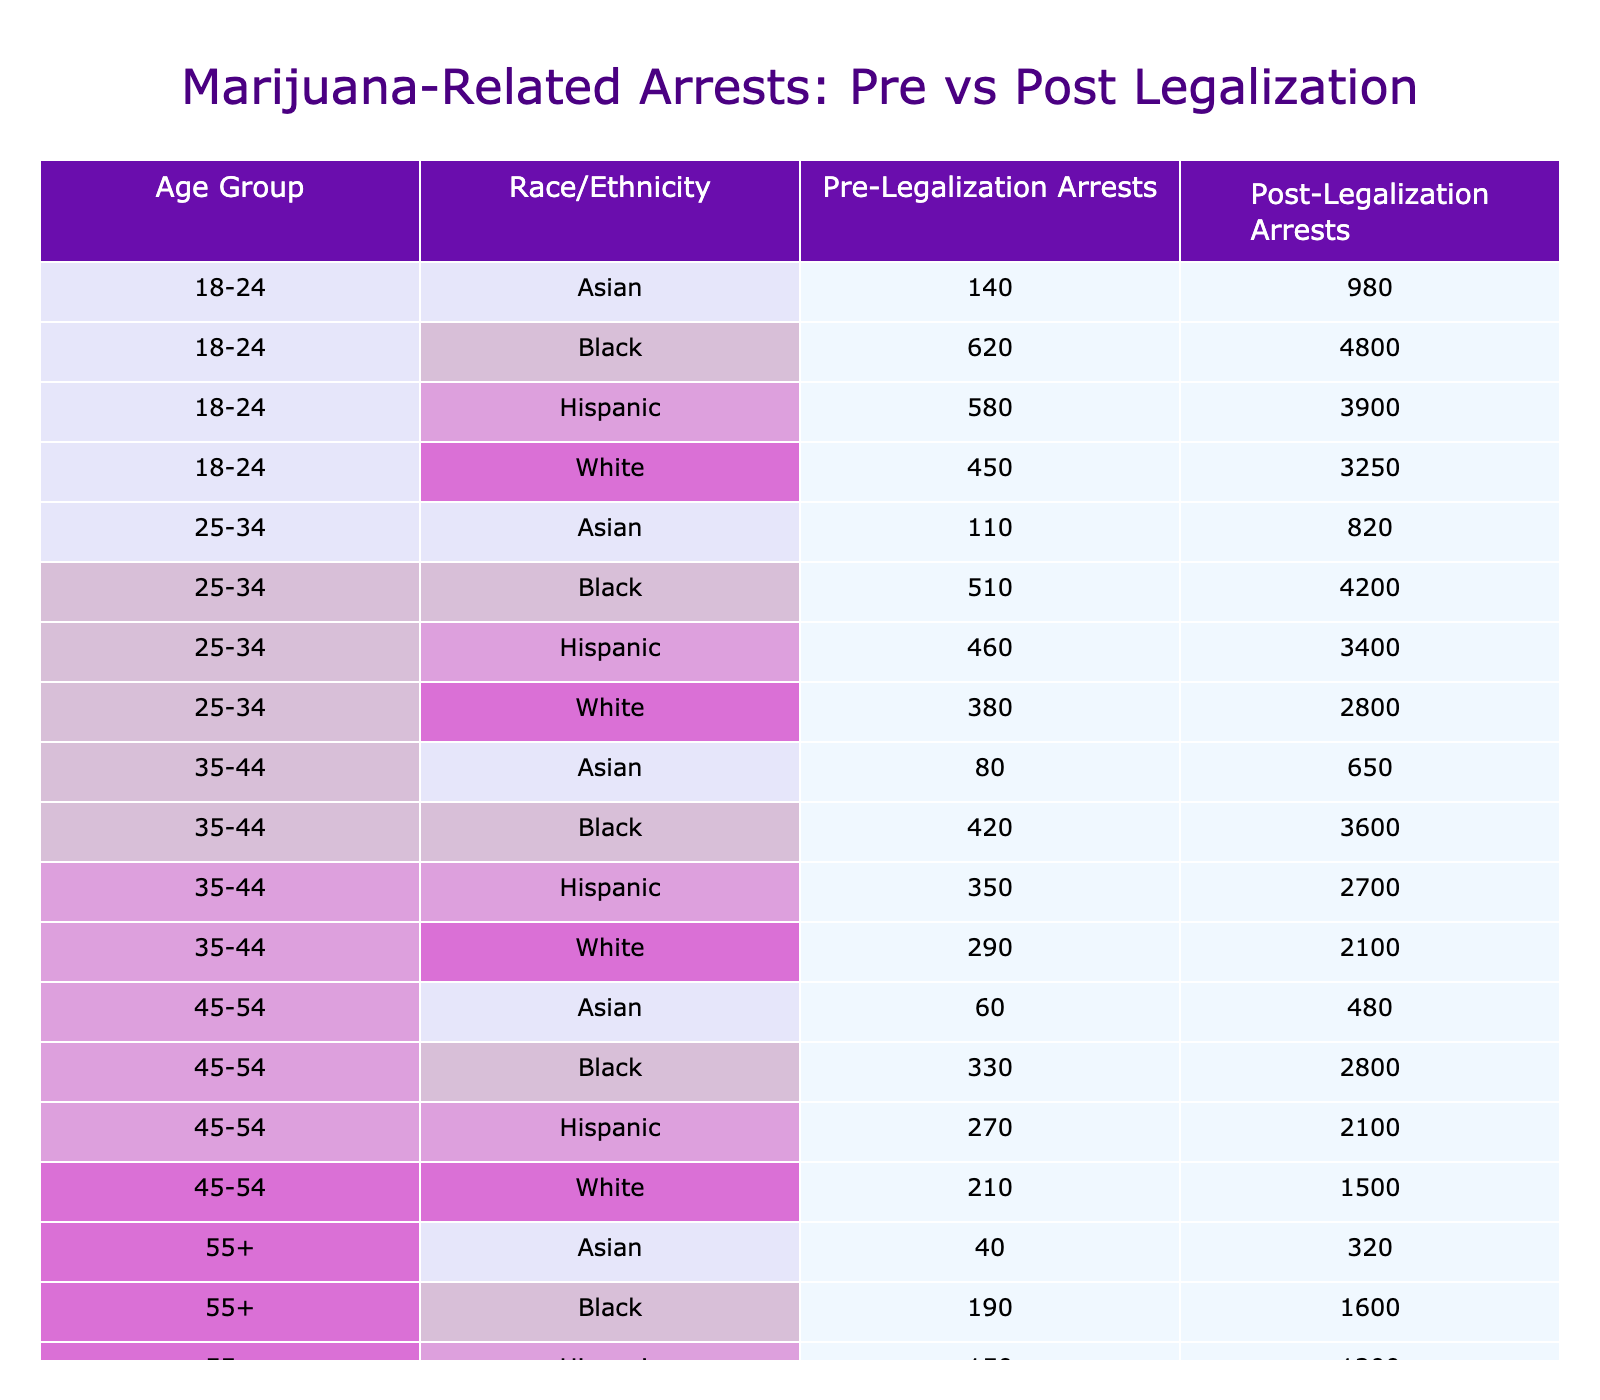What was the total number of pre-legalization arrests for Black individuals in the age group 25-34? The table shows that pre-legalization arrests for Black individuals aged 25-34 were 4200.
Answer: 4200 What was the decrease in arrests for Hispanic individuals in the age group 18-24 after legalization? Pre-legalization arrests for Hispanic individuals aged 18-24 were 3900 and post-legalization arrests were 580. The decrease is calculated as 3900 - 580 = 3320.
Answer: 3320 How many arrests were made post-legalization for individuals aged 55+? Summing all post-legalization arrests for individuals aged 55+ gives: 130 (White) + 190 (Black) + 150 (Hispanic) + 40 (Asian) = 510.
Answer: 510 Did the number of arrests for White individuals aged 35-44 decrease after legalization? Pre-legalization arrests for White individuals aged 35-44 were 2100, while post-legalization arrests were 290. Since 290 is less than 2100, the arrests did decrease.
Answer: Yes What is the average number of pre-legalization arrests across all age groups for Hispanic individuals? The pre-legalization arrests for Hispanic individuals are: 3900 (18-24) + 3400 (25-34) + 2700 (35-44) + 2100 (45-54) + 1200 (55+). The total is 3900 + 3400 + 2700 + 2100 + 1200 = 15300. The average is 15300 / 5 = 3060.
Answer: 3060 What percentage of pre-legalization arrests for Asian individuals aged 55+ were made after legalization? Pre-legalization arrests for Asian individuals aged 55+ were 320, and post-legalization arrests were 40. The percentage is calculated as (40 / 320) * 100 = 12.5%.
Answer: 12.5% Which age group experienced the largest decrease in arrests for Black individuals after legalization? The age groups for Black individuals with pre-legalization arrests are: 4800 (18-24), 4200 (25-34), 3600 (35-44), 2800 (45-54), and 1600 (55+). The largest decrease was from 4800 (18-24) to 620 (post-legalization), which is a decrease of 4180, the largest among all groups.
Answer: 18-24 What is the total number of arrests for White individuals before legalization across all age groups? Adding the pre-legalization arrests for White individuals: 3250 + 2800 + 2100 + 1500 + 980 = 10930.
Answer: 10930 Was the number of post-legalization arrests for Asian individuals aged 25-34 greater than for any other race/ethnicity? Post-legalization arrests for Asian individuals aged 25-34 were 110. Comparing with other races in the same age group: 380 (White), 510 (Black), and 460 (Hispanic), it's evident that 110 is not greater than these numbers.
Answer: No What is the ratio of pre-legalization arrests for individuals aged 45-54 compared to those aged 55+? Pre-legalization arrests for individuals aged 45-54 total 2100 (Hispanic) + 2800 (Black) + 1500 (White) + 480 (Asian) = 6880 for 45-54. For those aged 55+, it was 980 + 1600 + 1200 + 320 = 4100. The ratio is 6880:4100, simplified is approximately 1.68:1.
Answer: Approximately 1.68:1 